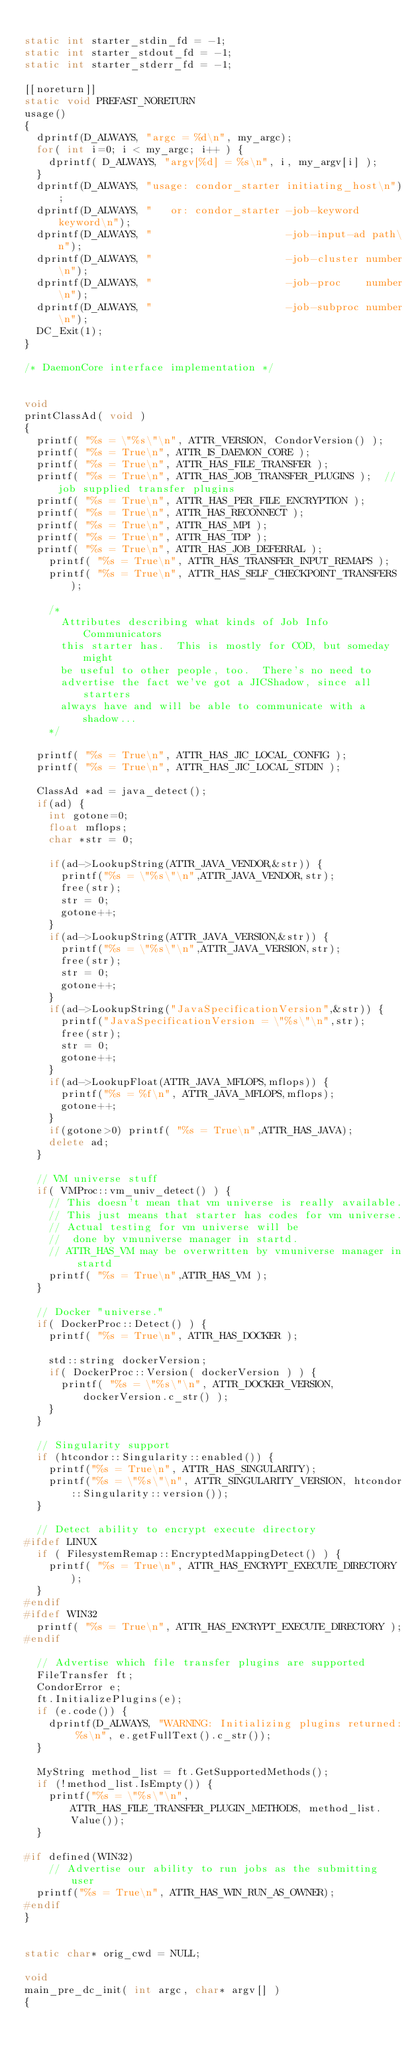Convert code to text. <code><loc_0><loc_0><loc_500><loc_500><_C++_>
static int starter_stdin_fd = -1;
static int starter_stdout_fd = -1;
static int starter_stderr_fd = -1;

[[noreturn]]
static void PREFAST_NORETURN
usage()
{
	dprintf(D_ALWAYS, "argc = %d\n", my_argc);
	for( int i=0; i < my_argc; i++ ) {
		dprintf( D_ALWAYS, "argv[%d] = %s\n", i, my_argv[i] );
	}
	dprintf(D_ALWAYS, "usage: condor_starter initiating_host\n");
	dprintf(D_ALWAYS, "   or: condor_starter -job-keyword keyword\n");
	dprintf(D_ALWAYS, "                      -job-input-ad path\n");
	dprintf(D_ALWAYS, "                      -job-cluster number\n");
	dprintf(D_ALWAYS, "                      -job-proc    number\n");
	dprintf(D_ALWAYS, "                      -job-subproc number\n");
	DC_Exit(1);
}

/* DaemonCore interface implementation */


void
printClassAd( void )
{
	printf( "%s = \"%s\"\n", ATTR_VERSION, CondorVersion() );
	printf( "%s = True\n", ATTR_IS_DAEMON_CORE );
	printf( "%s = True\n", ATTR_HAS_FILE_TRANSFER );
	printf( "%s = True\n", ATTR_HAS_JOB_TRANSFER_PLUGINS );	 // job supplied transfer plugins
	printf( "%s = True\n", ATTR_HAS_PER_FILE_ENCRYPTION );
	printf( "%s = True\n", ATTR_HAS_RECONNECT );
	printf( "%s = True\n", ATTR_HAS_MPI );
	printf( "%s = True\n", ATTR_HAS_TDP );
	printf( "%s = True\n", ATTR_HAS_JOB_DEFERRAL );
    printf( "%s = True\n", ATTR_HAS_TRANSFER_INPUT_REMAPS );
    printf( "%s = True\n", ATTR_HAS_SELF_CHECKPOINT_TRANSFERS );

		/*
		  Attributes describing what kinds of Job Info Communicators
		  this starter has.  This is mostly for COD, but someday might
		  be useful to other people, too.  There's no need to
		  advertise the fact we've got a JICShadow, since all starters
		  always have and will be able to communicate with a shadow...
		*/

	printf( "%s = True\n", ATTR_HAS_JIC_LOCAL_CONFIG );
	printf( "%s = True\n", ATTR_HAS_JIC_LOCAL_STDIN );

	ClassAd *ad = java_detect();
	if(ad) {
		int gotone=0;
		float mflops;
		char *str = 0;

		if(ad->LookupString(ATTR_JAVA_VENDOR,&str)) {
			printf("%s = \"%s\"\n",ATTR_JAVA_VENDOR,str);
			free(str);
			str = 0;
			gotone++;
		}
		if(ad->LookupString(ATTR_JAVA_VERSION,&str)) {
			printf("%s = \"%s\"\n",ATTR_JAVA_VERSION,str);
			free(str);
			str = 0;
			gotone++;
		}
		if(ad->LookupString("JavaSpecificationVersion",&str)) {
			printf("JavaSpecificationVersion = \"%s\"\n",str);
			free(str);
			str = 0;
			gotone++;
		}
		if(ad->LookupFloat(ATTR_JAVA_MFLOPS,mflops)) {
			printf("%s = %f\n", ATTR_JAVA_MFLOPS,mflops);
			gotone++;
		}
		if(gotone>0) printf( "%s = True\n",ATTR_HAS_JAVA);		
		delete ad;
	}

	// VM universe stuff
	if( VMProc::vm_univ_detect() ) {
		// This doesn't mean that vm universe is really available.
		// This just means that starter has codes for vm universe.
		// Actual testing for vm universe will be
		//  done by vmuniverse manager in startd.
		// ATTR_HAS_VM may be overwritten by vmuniverse manager in startd
		printf( "%s = True\n",ATTR_HAS_VM );
	}

	// Docker "universe."
	if( DockerProc::Detect() ) {
		printf( "%s = True\n", ATTR_HAS_DOCKER );

		std::string dockerVersion;
		if( DockerProc::Version( dockerVersion ) ) {
			printf( "%s = \"%s\"\n", ATTR_DOCKER_VERSION, dockerVersion.c_str() );
		}
	}

	// Singularity support
	if (htcondor::Singularity::enabled()) {
		printf("%s = True\n", ATTR_HAS_SINGULARITY);
		printf("%s = \"%s\"\n", ATTR_SINGULARITY_VERSION, htcondor::Singularity::version());
	}

	// Detect ability to encrypt execute directory
#ifdef LINUX
	if ( FilesystemRemap::EncryptedMappingDetect() ) {
		printf( "%s = True\n", ATTR_HAS_ENCRYPT_EXECUTE_DIRECTORY );
	}
#endif
#ifdef WIN32
	printf( "%s = True\n", ATTR_HAS_ENCRYPT_EXECUTE_DIRECTORY );
#endif

	// Advertise which file transfer plugins are supported
	FileTransfer ft;
	CondorError e;
	ft.InitializePlugins(e);
	if (e.code()) {
		dprintf(D_ALWAYS, "WARNING: Initializing plugins returned: %s\n", e.getFullText().c_str());
	}

	MyString method_list = ft.GetSupportedMethods();
	if (!method_list.IsEmpty()) {
		printf("%s = \"%s\"\n", ATTR_HAS_FILE_TRANSFER_PLUGIN_METHODS, method_list.Value());
	}

#if defined(WIN32)
		// Advertise our ability to run jobs as the submitting user
	printf("%s = True\n", ATTR_HAS_WIN_RUN_AS_OWNER);
#endif
}


static char* orig_cwd = NULL;

void
main_pre_dc_init( int argc, char* argv[] )
{	</code> 